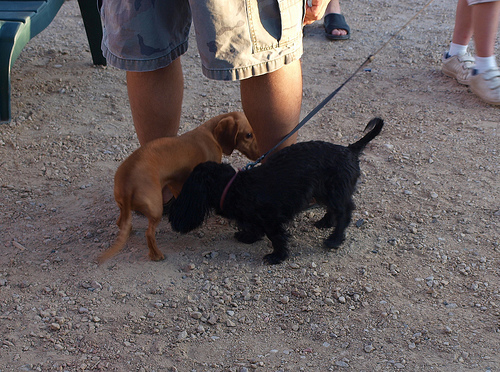<image>
Is there a dog brown on the dog black? No. The dog brown is not positioned on the dog black. They may be near each other, but the dog brown is not supported by or resting on top of the dog black. Is there a puppy to the left of the puppy? No. The puppy is not to the left of the puppy. From this viewpoint, they have a different horizontal relationship. Is the dog next to the legs? Yes. The dog is positioned adjacent to the legs, located nearby in the same general area. Where is the dog in relation to the pants? Is it in front of the pants? No. The dog is not in front of the pants. The spatial positioning shows a different relationship between these objects. 